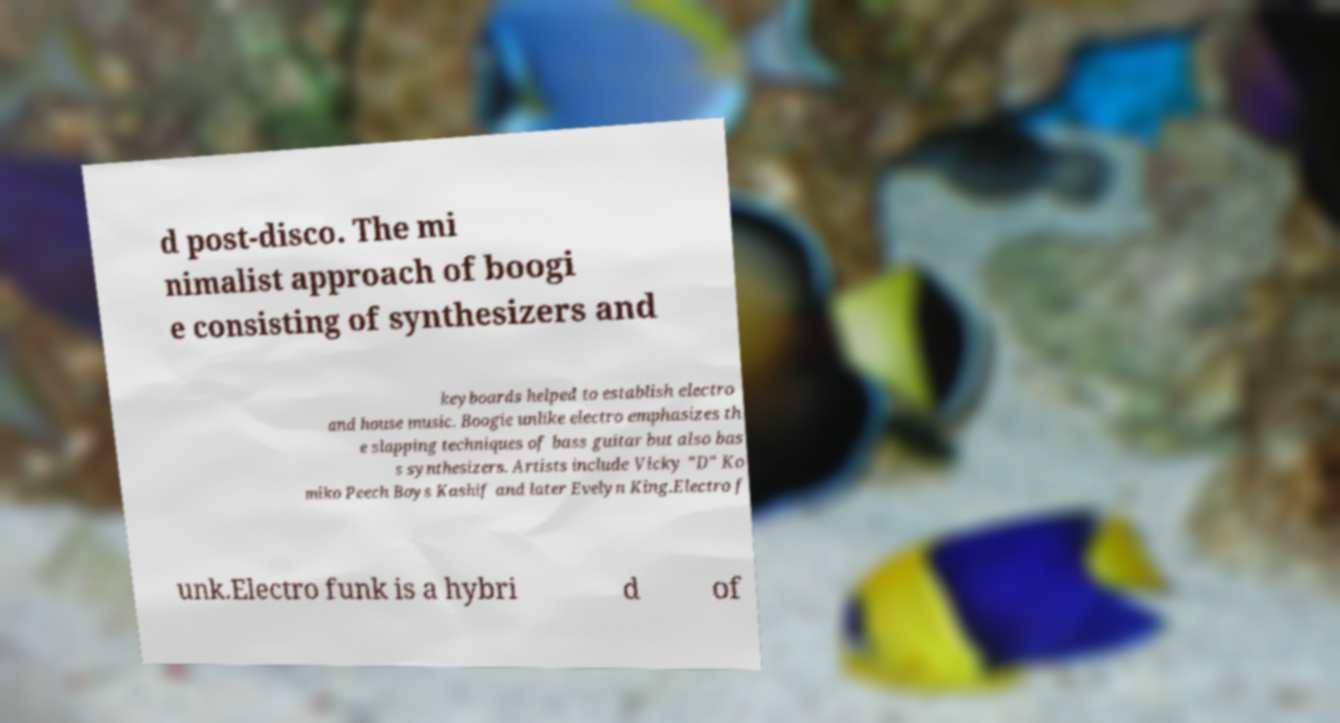Could you assist in decoding the text presented in this image and type it out clearly? d post-disco. The mi nimalist approach of boogi e consisting of synthesizers and keyboards helped to establish electro and house music. Boogie unlike electro emphasizes th e slapping techniques of bass guitar but also bas s synthesizers. Artists include Vicky "D" Ko miko Peech Boys Kashif and later Evelyn King.Electro f unk.Electro funk is a hybri d of 